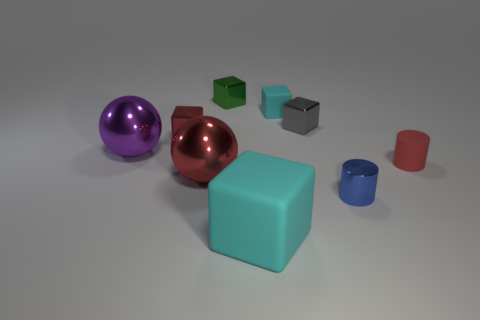How many things are in front of the tiny rubber cylinder and on the left side of the blue metallic thing? There appears to be one small object, specifically a gray cube, situated in front of the tiny rubber cylinder and to the left of the large blue cube, which could be described as metallic in appearance. 